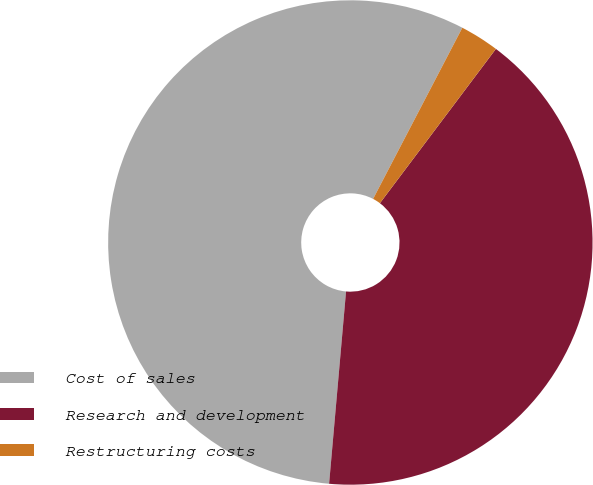<chart> <loc_0><loc_0><loc_500><loc_500><pie_chart><fcel>Cost of sales<fcel>Research and development<fcel>Restructuring costs<nl><fcel>56.25%<fcel>41.14%<fcel>2.61%<nl></chart> 